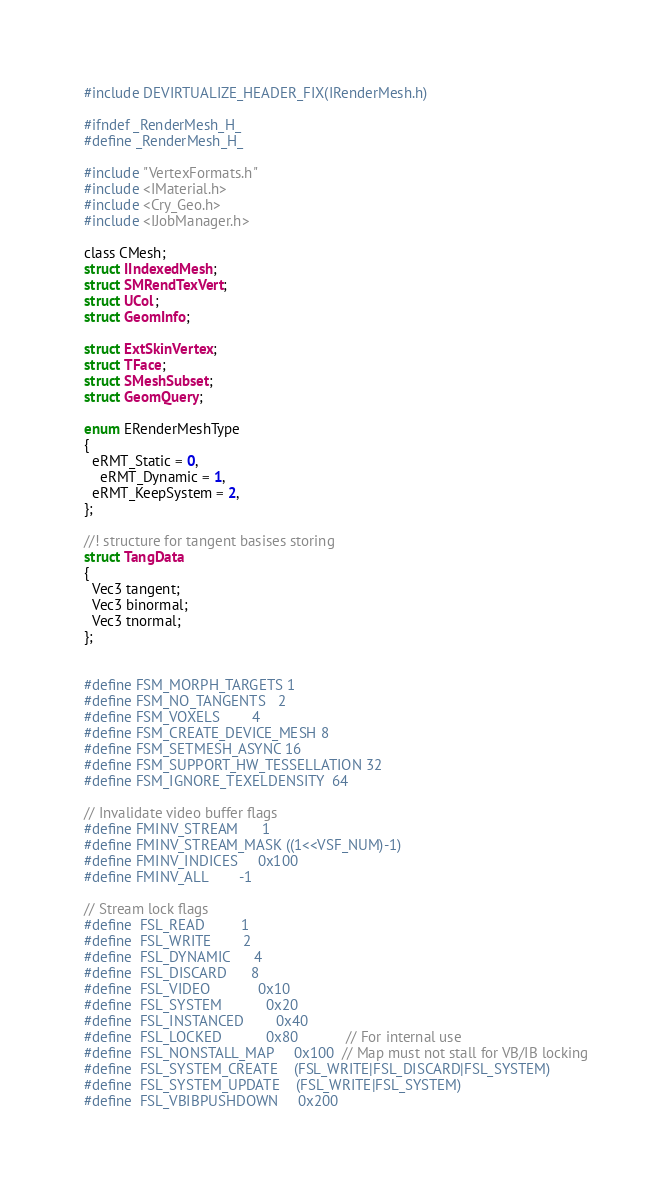Convert code to text. <code><loc_0><loc_0><loc_500><loc_500><_C_>#include DEVIRTUALIZE_HEADER_FIX(IRenderMesh.h)

#ifndef _RenderMesh_H_
#define _RenderMesh_H_

#include "VertexFormats.h"
#include <IMaterial.h>
#include <Cry_Geo.h>
#include <IJobManager.h>

class CMesh;
struct IIndexedMesh;
struct SMRendTexVert;
struct UCol;
struct GeomInfo;

struct ExtSkinVertex;
struct TFace;
struct SMeshSubset;
struct GeomQuery;

enum ERenderMeshType
{
  eRMT_Static = 0,
	eRMT_Dynamic = 1, 
  eRMT_KeepSystem = 2,
};

//! structure for tangent basises storing
struct TangData
{
  Vec3 tangent;
  Vec3 binormal;      
  Vec3 tnormal;     
};


#define FSM_MORPH_TARGETS 1
#define FSM_NO_TANGENTS   2
#define FSM_VOXELS        4
#define FSM_CREATE_DEVICE_MESH 8
#define FSM_SETMESH_ASYNC 16
#define FSM_SUPPORT_HW_TESSELLATION 32
#define FSM_IGNORE_TEXELDENSITY	64

// Invalidate video buffer flags
#define FMINV_STREAM      1
#define FMINV_STREAM_MASK ((1<<VSF_NUM)-1)
#define FMINV_INDICES     0x100
#define FMINV_ALL        -1

// Stream lock flags
#define  FSL_READ         1
#define  FSL_WRITE        2
#define  FSL_DYNAMIC      4
#define  FSL_DISCARD      8
#define  FSL_VIDEO            0x10
#define  FSL_SYSTEM           0x20
#define  FSL_INSTANCED        0x40 
#define  FSL_LOCKED           0x80			 // For internal use
#define  FSL_NONSTALL_MAP     0x100  // Map must not stall for VB/IB locking
#define  FSL_SYSTEM_CREATE    (FSL_WRITE|FSL_DISCARD|FSL_SYSTEM)
#define  FSL_SYSTEM_UPDATE    (FSL_WRITE|FSL_SYSTEM)
#define  FSL_VBIBPUSHDOWN     0x200 
</code> 